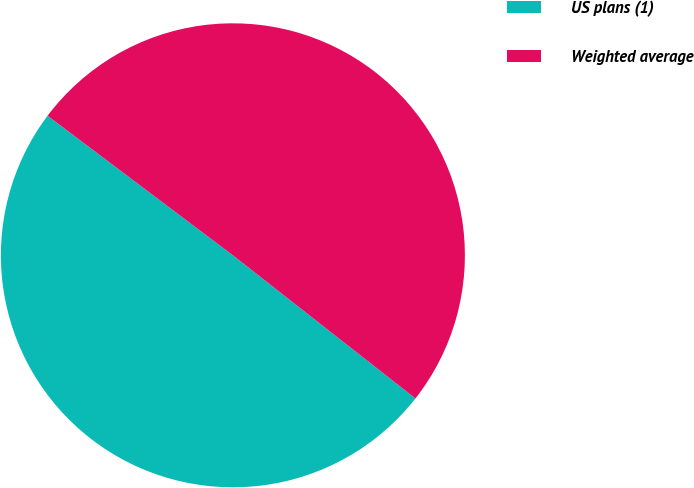Convert chart to OTSL. <chart><loc_0><loc_0><loc_500><loc_500><pie_chart><fcel>US plans (1)<fcel>Weighted average<nl><fcel>49.69%<fcel>50.31%<nl></chart> 